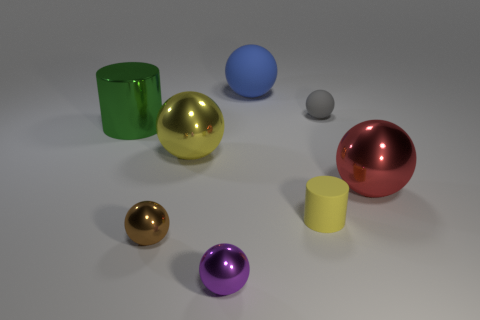Subtract all yellow spheres. How many spheres are left? 5 Add 1 big objects. How many objects exist? 9 Subtract all gray balls. How many balls are left? 5 Subtract all spheres. How many objects are left? 2 Subtract 2 cylinders. How many cylinders are left? 0 Subtract all small shiny cylinders. Subtract all large blue rubber spheres. How many objects are left? 7 Add 1 blue rubber things. How many blue rubber things are left? 2 Add 3 small yellow cylinders. How many small yellow cylinders exist? 4 Subtract 0 brown cylinders. How many objects are left? 8 Subtract all gray spheres. Subtract all purple blocks. How many spheres are left? 5 